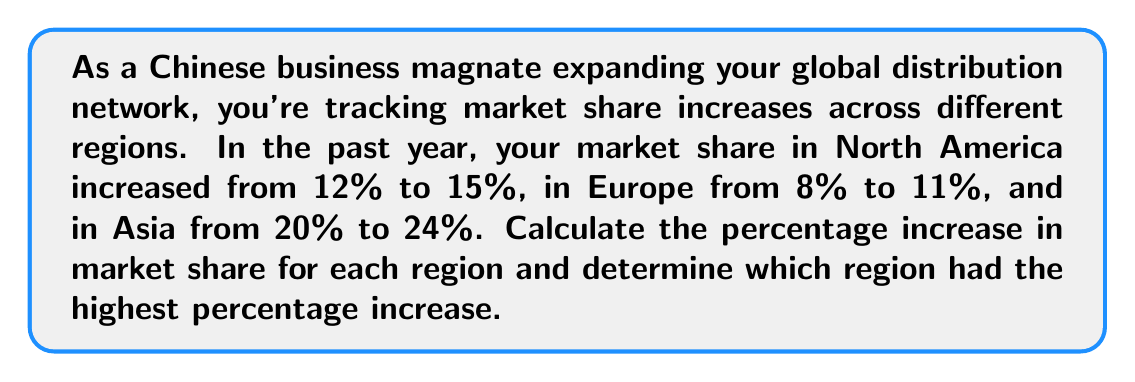Give your solution to this math problem. To calculate the percentage increase in market share for each region, we'll use the formula:

$$ \text{Percentage Increase} = \frac{\text{New Value} - \text{Original Value}}{\text{Original Value}} \times 100\% $$

1. North America:
   $$ \text{Percentage Increase} = \frac{15\% - 12\%}{12\%} \times 100\% = \frac{3\%}{12\%} \times 100\% = 25\% $$

2. Europe:
   $$ \text{Percentage Increase} = \frac{11\% - 8\%}{8\%} \times 100\% = \frac{3\%}{8\%} \times 100\% = 37.5\% $$

3. Asia:
   $$ \text{Percentage Increase} = \frac{24\% - 20\%}{20\%} \times 100\% = \frac{4\%}{20\%} \times 100\% = 20\% $$

Comparing the percentage increases:
North America: 25%
Europe: 37.5%
Asia: 20%

Europe had the highest percentage increase in market share.
Answer: North America: 25% increase
Europe: 37.5% increase
Asia: 20% increase

Europe had the highest percentage increase in market share at 37.5%. 